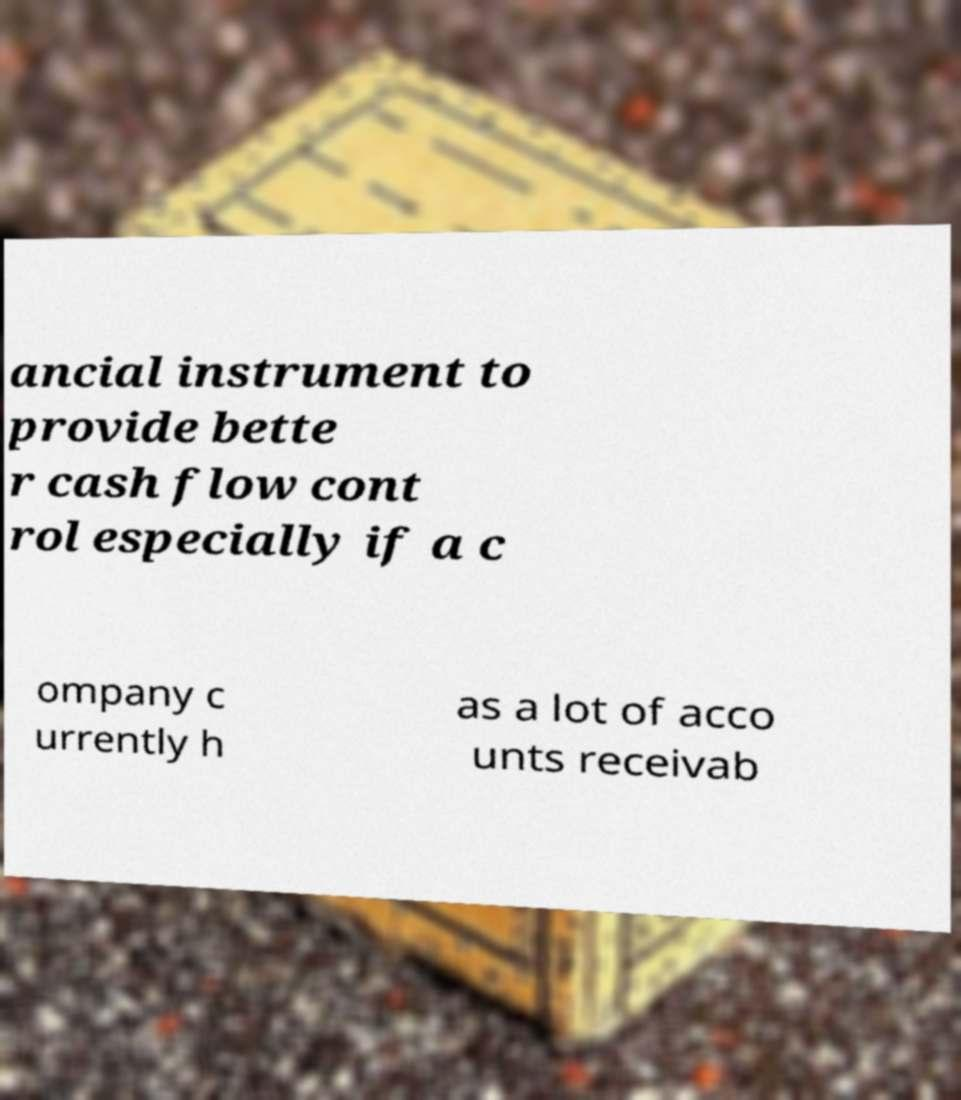Please read and relay the text visible in this image. What does it say? ancial instrument to provide bette r cash flow cont rol especially if a c ompany c urrently h as a lot of acco unts receivab 